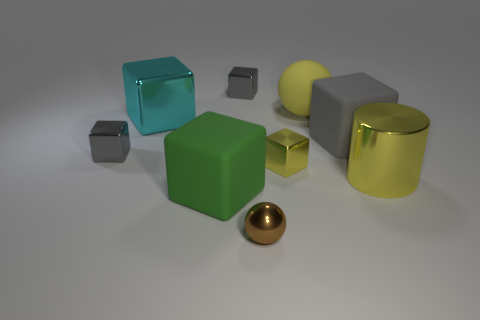Subtract all yellow balls. How many gray blocks are left? 3 Subtract all cyan cubes. How many cubes are left? 5 Subtract all large matte cubes. How many cubes are left? 4 Subtract 2 cubes. How many cubes are left? 4 Subtract all green blocks. Subtract all green spheres. How many blocks are left? 5 Add 1 cyan matte balls. How many objects exist? 10 Subtract all balls. How many objects are left? 7 Add 9 small metal balls. How many small metal balls exist? 10 Subtract 0 blue cylinders. How many objects are left? 9 Subtract all large blue shiny balls. Subtract all large green objects. How many objects are left? 8 